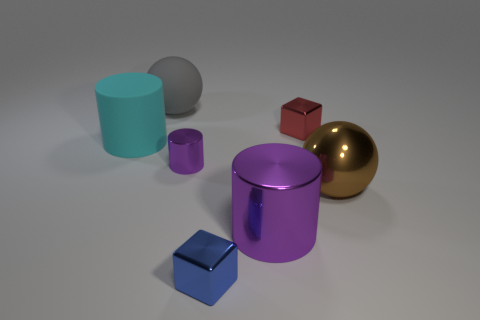Subtract all rubber cylinders. How many cylinders are left? 2 Subtract all gray balls. How many balls are left? 1 Add 2 tiny objects. How many objects exist? 9 Subtract all blocks. How many objects are left? 5 Add 7 cyan matte cylinders. How many cyan matte cylinders are left? 8 Add 5 big rubber things. How many big rubber things exist? 7 Subtract 0 blue balls. How many objects are left? 7 Subtract 1 balls. How many balls are left? 1 Subtract all blue spheres. Subtract all gray cylinders. How many spheres are left? 2 Subtract all gray cylinders. How many cyan cubes are left? 0 